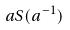<formula> <loc_0><loc_0><loc_500><loc_500>a S ( a ^ { - 1 } )</formula> 